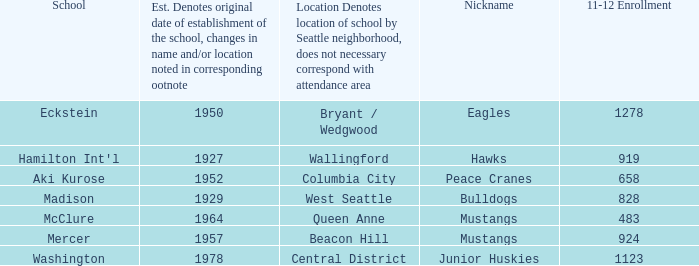Name the school for columbia city Aki Kurose. 